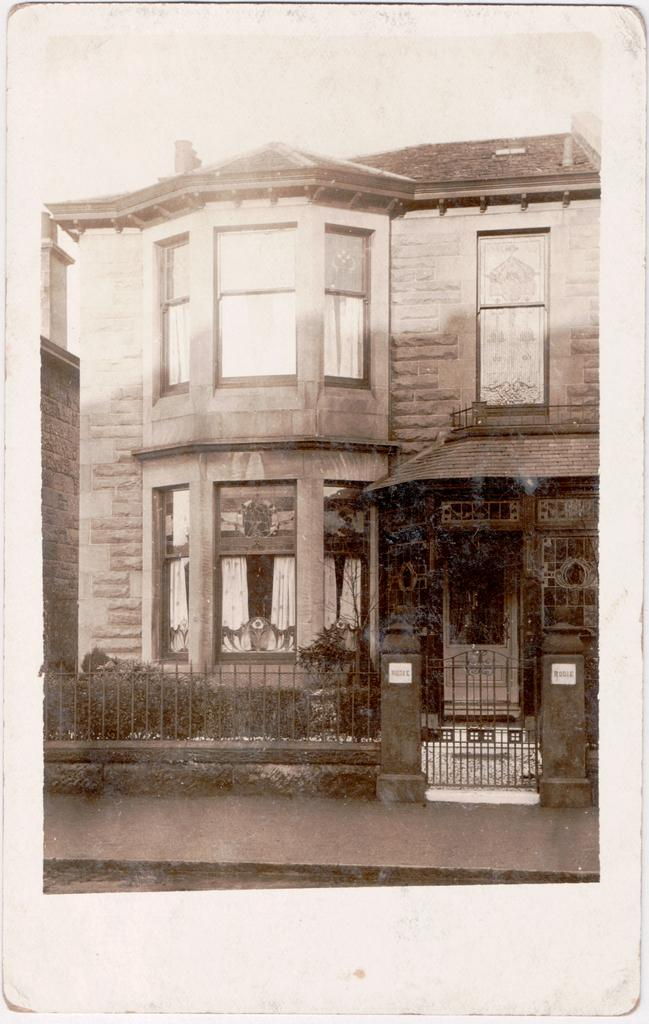What type of structure can be seen in the background of the image? There is a building in the background of the image. What is located in front of the building? There are plants and a fence in front of the building. Is there any entrance or exit visible in front of the building? Yes, there is a gate in front of the building. What type of nose can be seen on the building in the image? There is no nose present on the building in the image. What type of bait is being used to catch fish in the image? There is no fishing or bait present in the image. 